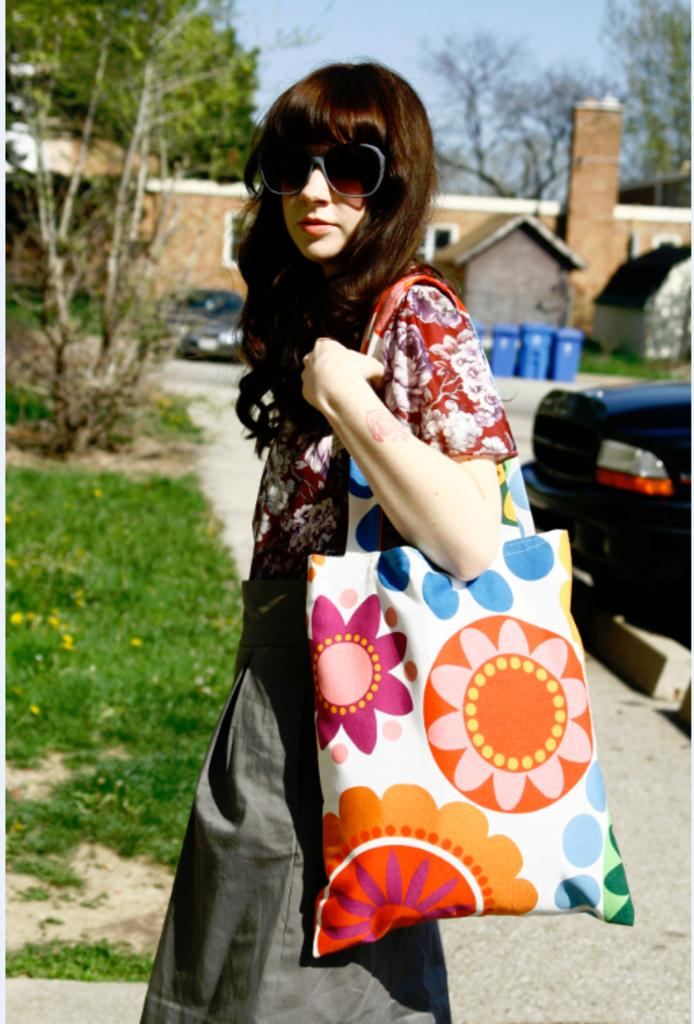What is the person in the image wearing on their upper body? The person is wearing a red floral shirt. What type of clothing is the person wearing on their lower body? The person is wearing a skirt. What accessory is the person carrying in the image? The person is carrying a floral handbag. What can be seen on the left side of the image? There is grass and trees on the left side of the image. What is visible on the right side of the image? There is a car on the right side of the image. What structure can be seen in the background of the image? There is a building visible in the background. How much does the giant weigh in the image? There are no giants present in the image, so it is not possible to determine their weight. 